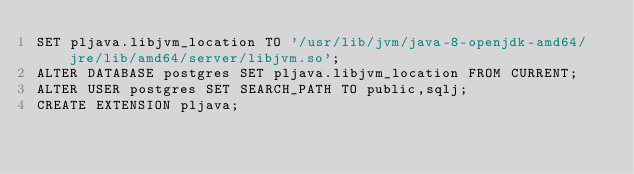<code> <loc_0><loc_0><loc_500><loc_500><_SQL_>SET pljava.libjvm_location TO '/usr/lib/jvm/java-8-openjdk-amd64/jre/lib/amd64/server/libjvm.so';
ALTER DATABASE postgres SET pljava.libjvm_location FROM CURRENT;
ALTER USER postgres SET SEARCH_PATH TO public,sqlj;
CREATE EXTENSION pljava;</code> 